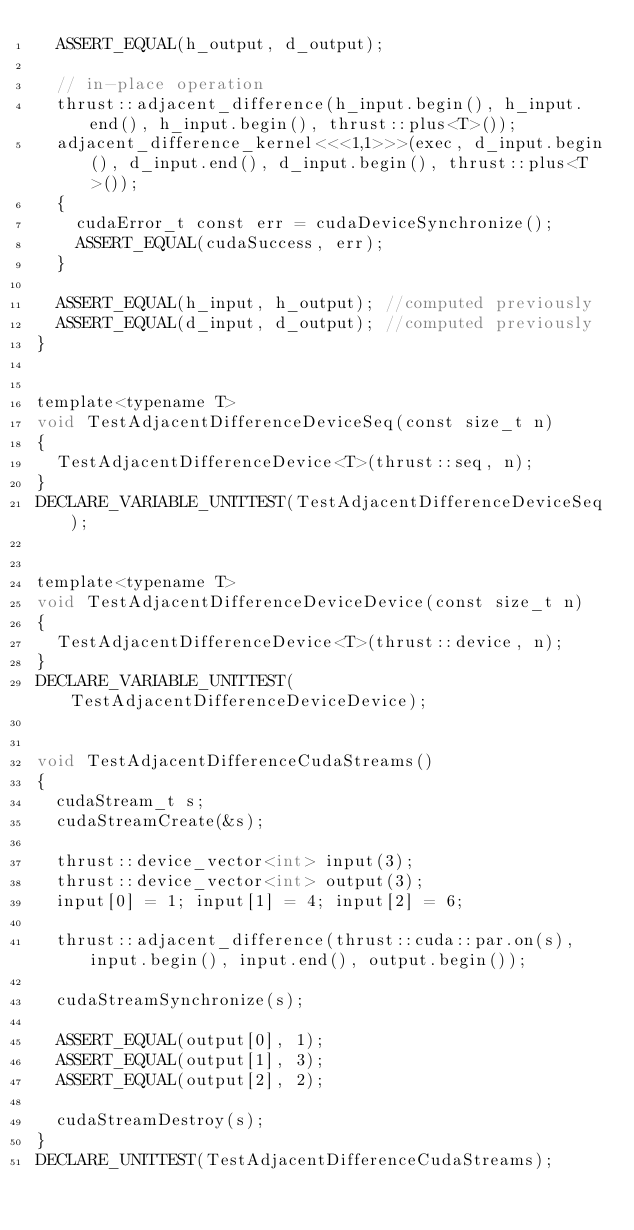<code> <loc_0><loc_0><loc_500><loc_500><_Cuda_>  ASSERT_EQUAL(h_output, d_output);
  
  // in-place operation
  thrust::adjacent_difference(h_input.begin(), h_input.end(), h_input.begin(), thrust::plus<T>());
  adjacent_difference_kernel<<<1,1>>>(exec, d_input.begin(), d_input.end(), d_input.begin(), thrust::plus<T>());
  {
    cudaError_t const err = cudaDeviceSynchronize();
    ASSERT_EQUAL(cudaSuccess, err);
  }
  
  ASSERT_EQUAL(h_input, h_output); //computed previously
  ASSERT_EQUAL(d_input, d_output); //computed previously
}


template<typename T>
void TestAdjacentDifferenceDeviceSeq(const size_t n)
{
  TestAdjacentDifferenceDevice<T>(thrust::seq, n);
}
DECLARE_VARIABLE_UNITTEST(TestAdjacentDifferenceDeviceSeq);


template<typename T>
void TestAdjacentDifferenceDeviceDevice(const size_t n)
{
  TestAdjacentDifferenceDevice<T>(thrust::device, n);
}
DECLARE_VARIABLE_UNITTEST(TestAdjacentDifferenceDeviceDevice);


void TestAdjacentDifferenceCudaStreams()
{
  cudaStream_t s;
  cudaStreamCreate(&s);
  
  thrust::device_vector<int> input(3);
  thrust::device_vector<int> output(3);
  input[0] = 1; input[1] = 4; input[2] = 6;
  
  thrust::adjacent_difference(thrust::cuda::par.on(s), input.begin(), input.end(), output.begin());

  cudaStreamSynchronize(s);
  
  ASSERT_EQUAL(output[0], 1);
  ASSERT_EQUAL(output[1], 3);
  ASSERT_EQUAL(output[2], 2);

  cudaStreamDestroy(s);
}
DECLARE_UNITTEST(TestAdjacentDifferenceCudaStreams);

</code> 